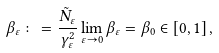Convert formula to latex. <formula><loc_0><loc_0><loc_500><loc_500>\beta _ { \varepsilon } \colon = \frac { \tilde { N } _ { \varepsilon } } { \gamma _ { \varepsilon } ^ { 2 } } \lim _ { \varepsilon \to 0 } \beta _ { \varepsilon } = \beta _ { 0 } \in [ 0 , 1 ] \, ,</formula> 